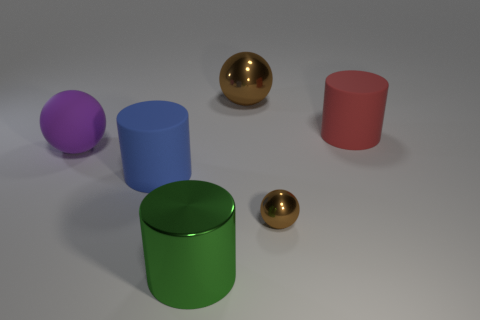There is a matte object to the left of the blue cylinder; does it have the same shape as the blue object?
Provide a short and direct response. No. The metallic ball left of the metallic thing right of the brown metallic sphere behind the large red rubber cylinder is what color?
Your answer should be compact. Brown. Are any big green shiny things visible?
Ensure brevity in your answer.  Yes. How many other objects are the same size as the metal cylinder?
Offer a terse response. 4. Do the large metallic sphere and the large shiny thing in front of the purple matte ball have the same color?
Provide a succinct answer. No. How many objects are either tiny yellow objects or blue cylinders?
Your answer should be compact. 1. Is there anything else of the same color as the big shiny cylinder?
Provide a short and direct response. No. Is the material of the small brown ball the same as the brown ball behind the red thing?
Offer a terse response. Yes. The brown object in front of the big metal thing that is behind the large red matte cylinder is what shape?
Offer a terse response. Sphere. What is the shape of the rubber thing that is both behind the big blue thing and on the right side of the big purple matte object?
Your answer should be compact. Cylinder. 